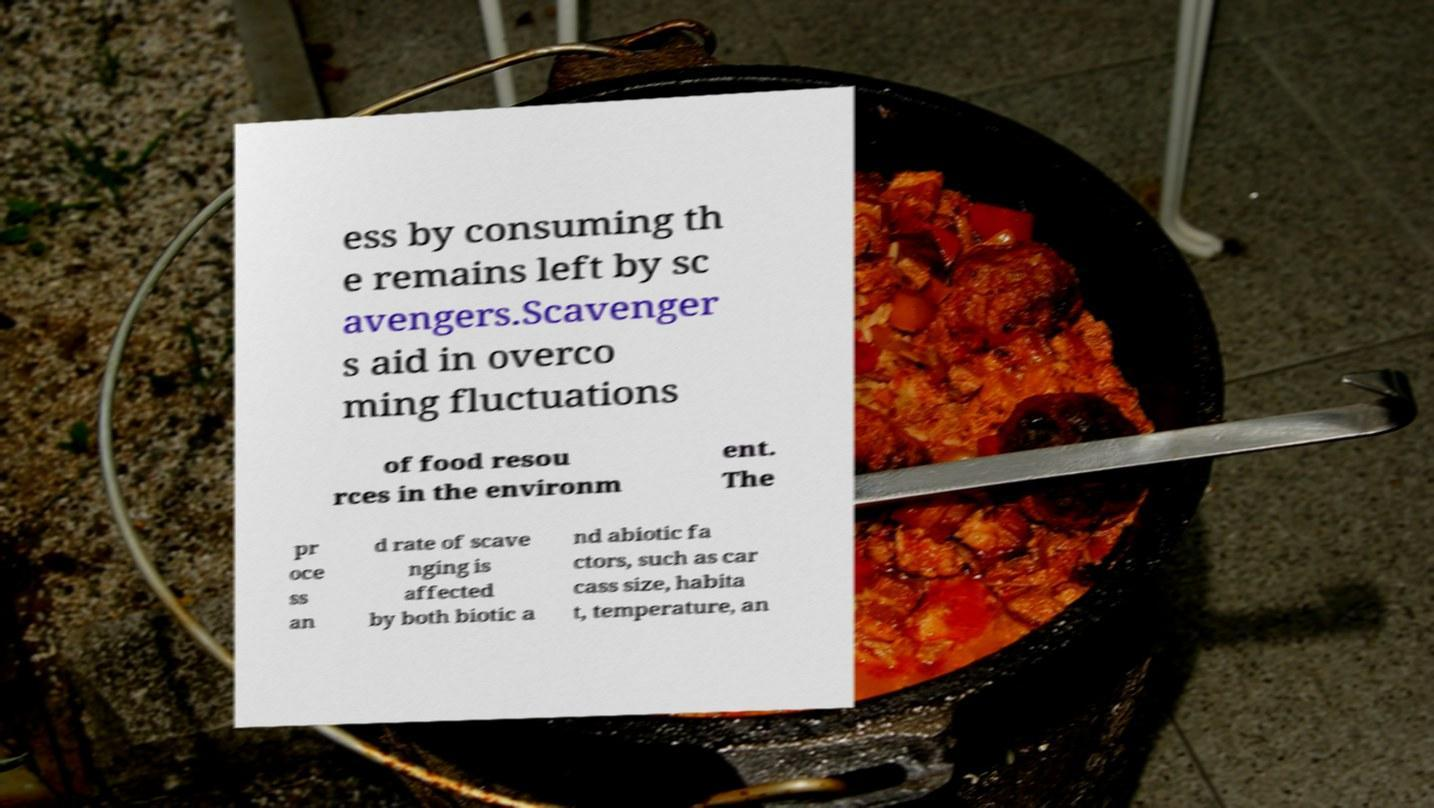Could you assist in decoding the text presented in this image and type it out clearly? ess by consuming th e remains left by sc avengers.Scavenger s aid in overco ming fluctuations of food resou rces in the environm ent. The pr oce ss an d rate of scave nging is affected by both biotic a nd abiotic fa ctors, such as car cass size, habita t, temperature, an 